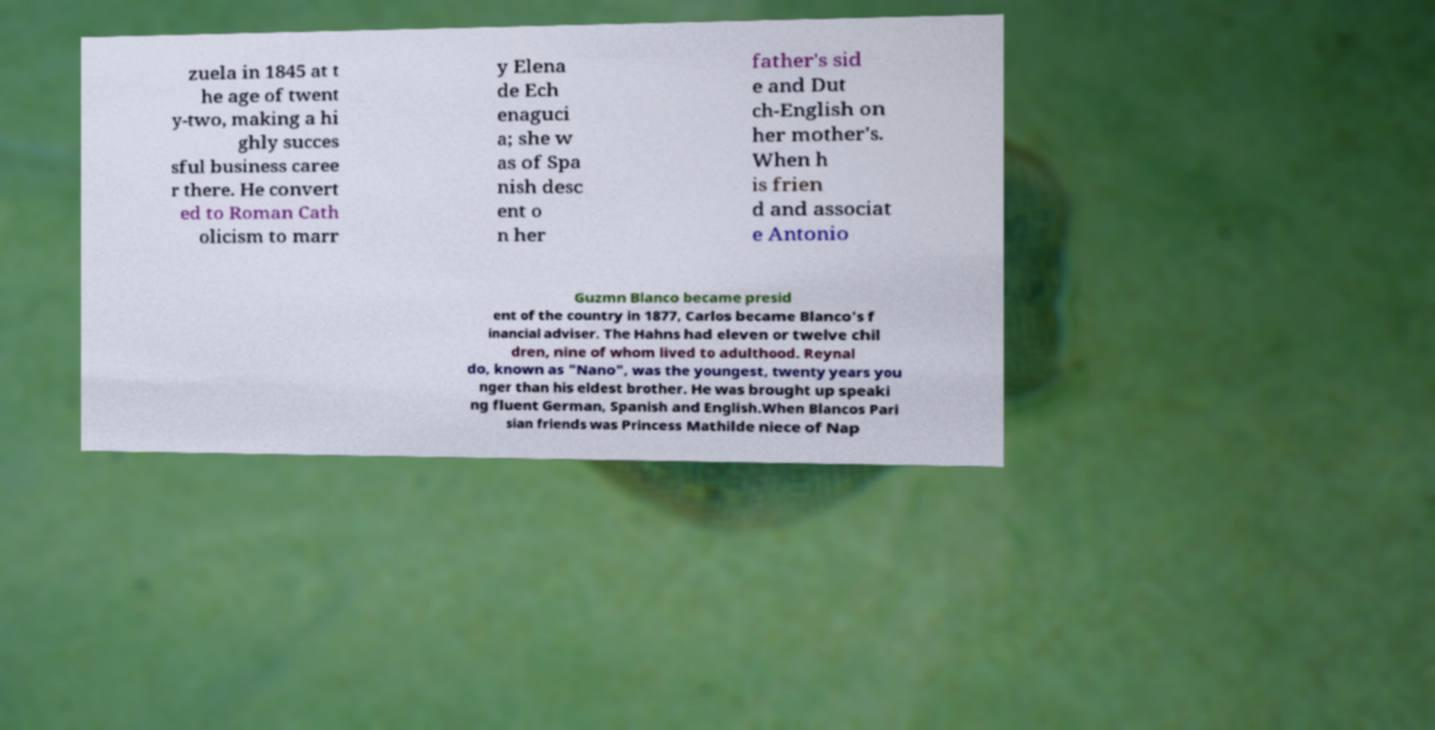For documentation purposes, I need the text within this image transcribed. Could you provide that? zuela in 1845 at t he age of twent y-two, making a hi ghly succes sful business caree r there. He convert ed to Roman Cath olicism to marr y Elena de Ech enaguci a; she w as of Spa nish desc ent o n her father's sid e and Dut ch-English on her mother's. When h is frien d and associat e Antonio Guzmn Blanco became presid ent of the country in 1877, Carlos became Blanco's f inancial adviser. The Hahns had eleven or twelve chil dren, nine of whom lived to adulthood. Reynal do, known as "Nano", was the youngest, twenty years you nger than his eldest brother. He was brought up speaki ng fluent German, Spanish and English.When Blancos Pari sian friends was Princess Mathilde niece of Nap 